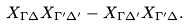Convert formula to latex. <formula><loc_0><loc_0><loc_500><loc_500>X _ { \Gamma \Delta } X _ { \Gamma ^ { \prime } \Delta ^ { \prime } } - X _ { \Gamma \Delta ^ { \prime } } X _ { \Gamma ^ { \prime } \Delta } .</formula> 